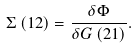<formula> <loc_0><loc_0><loc_500><loc_500>\Sigma \left ( 1 2 \right ) = \frac { \delta \Phi } { \delta G \left ( 2 1 \right ) } .</formula> 